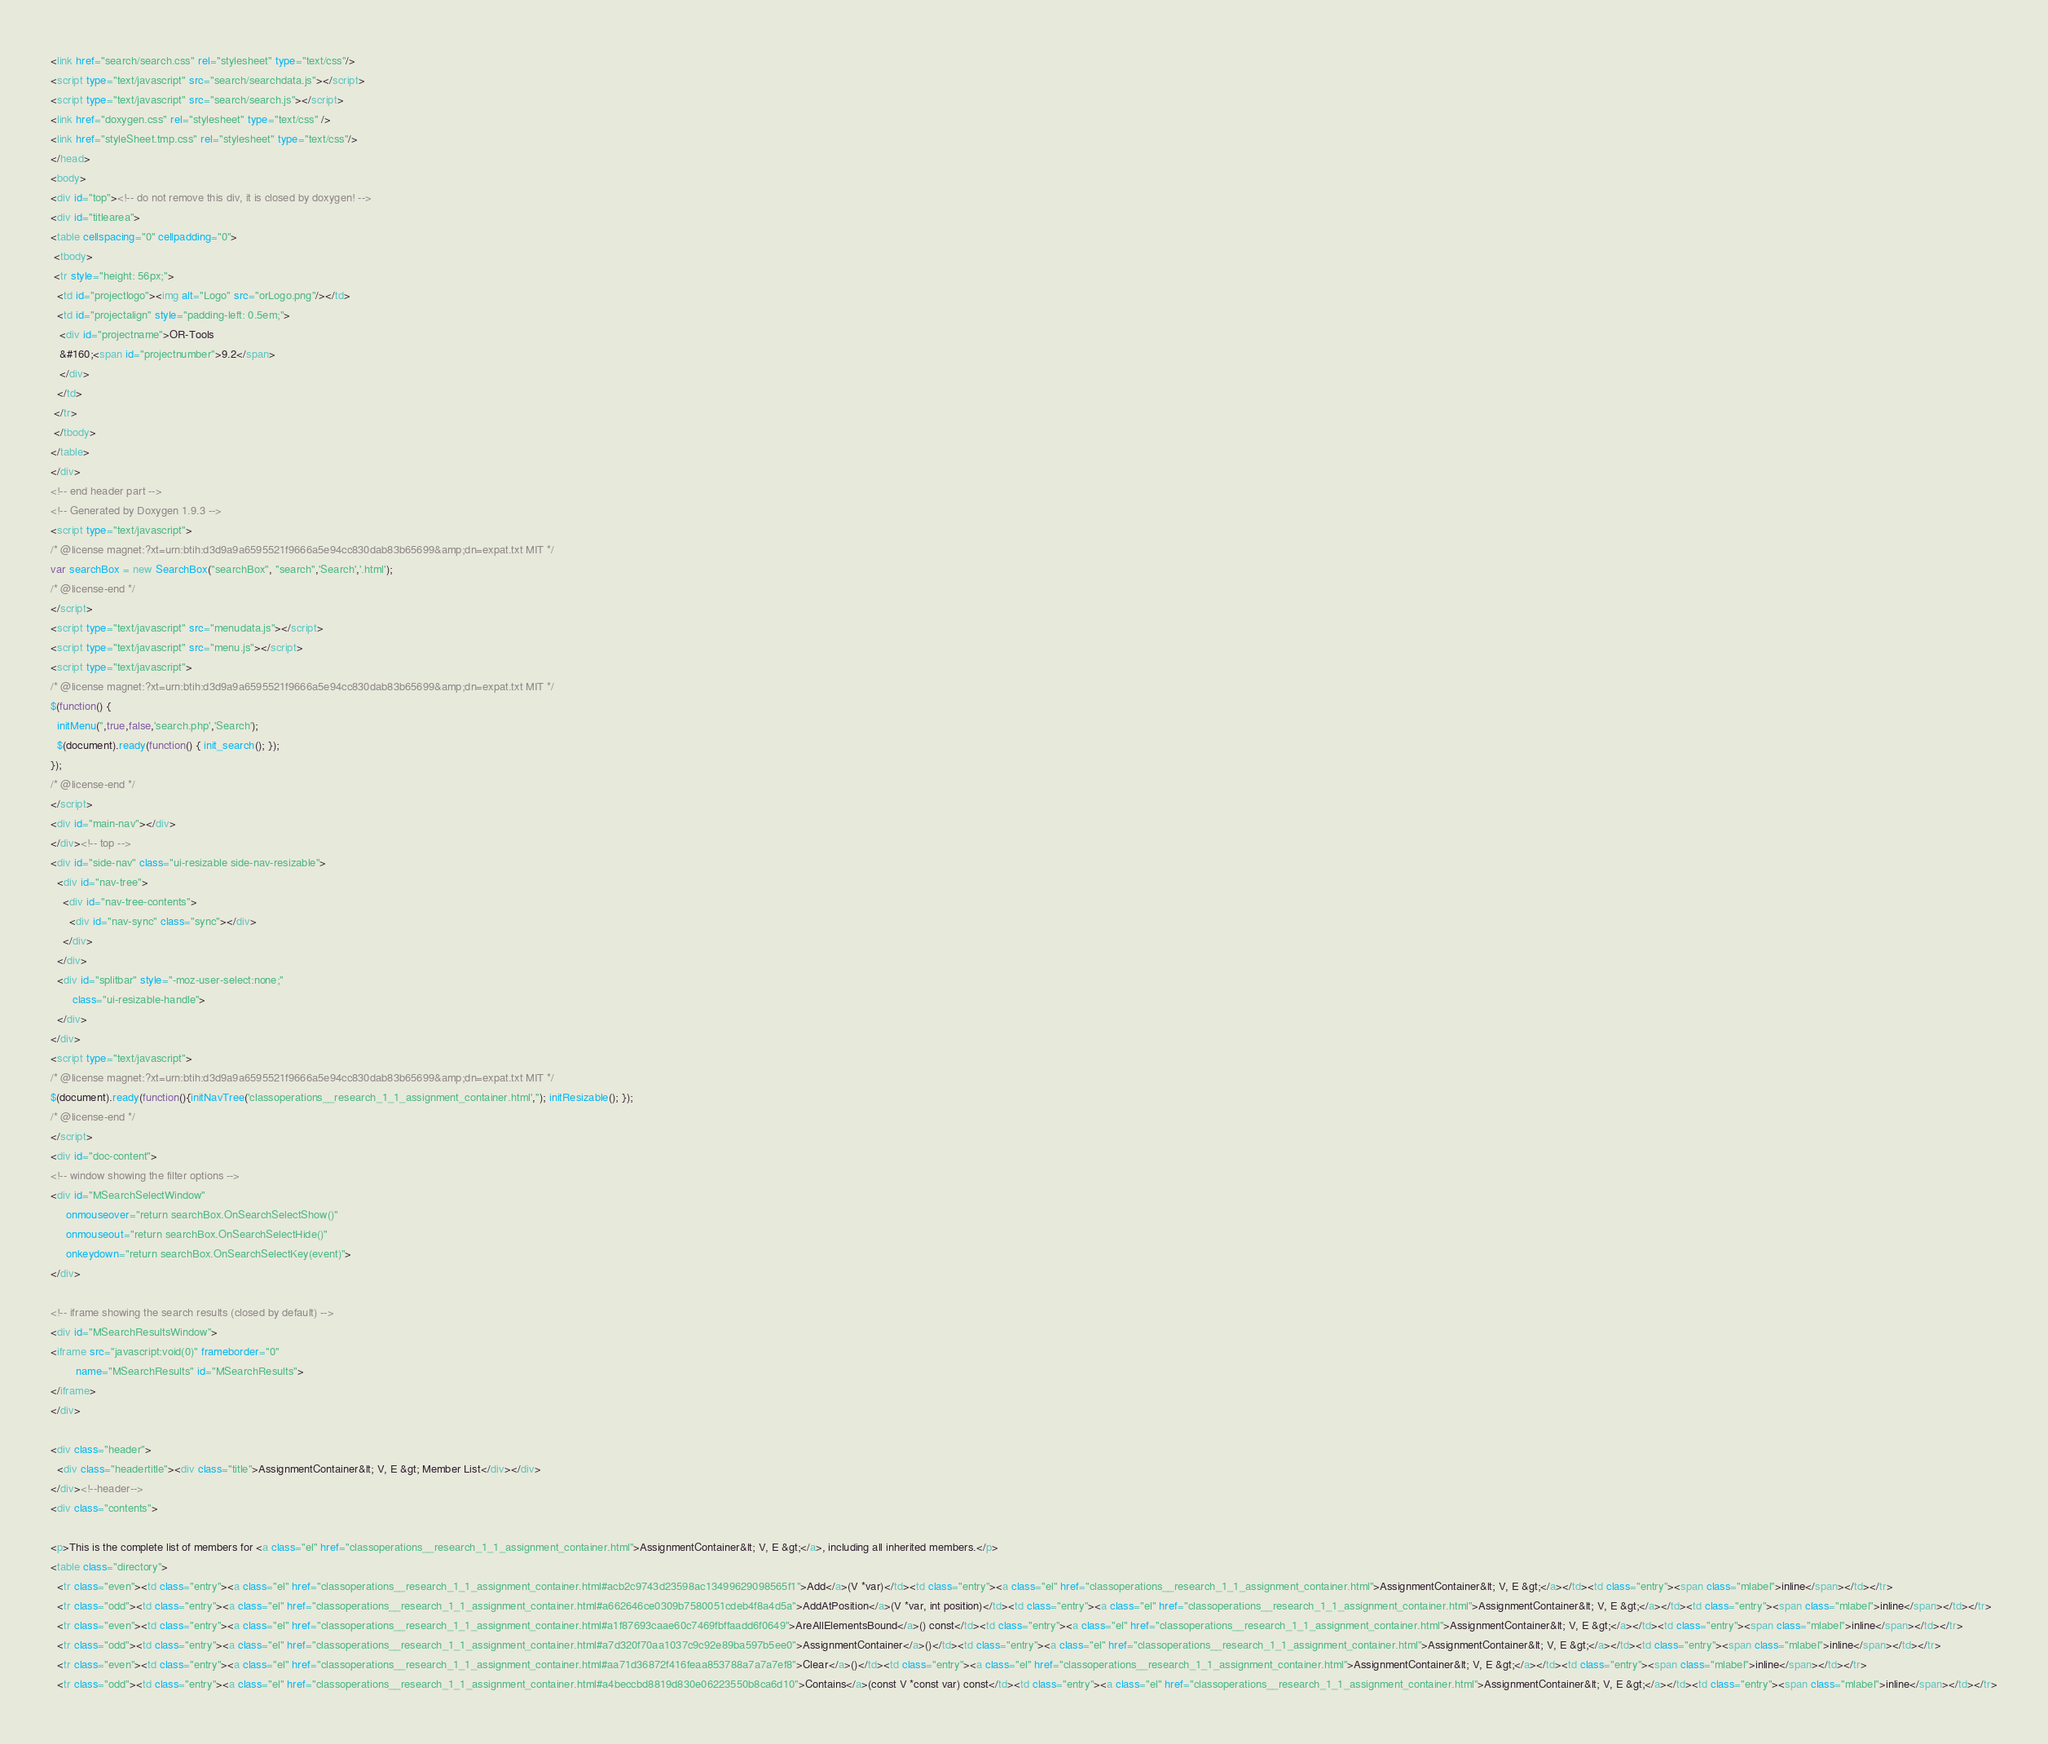<code> <loc_0><loc_0><loc_500><loc_500><_HTML_><link href="search/search.css" rel="stylesheet" type="text/css"/>
<script type="text/javascript" src="search/searchdata.js"></script>
<script type="text/javascript" src="search/search.js"></script>
<link href="doxygen.css" rel="stylesheet" type="text/css" />
<link href="styleSheet.tmp.css" rel="stylesheet" type="text/css"/>
</head>
<body>
<div id="top"><!-- do not remove this div, it is closed by doxygen! -->
<div id="titlearea">
<table cellspacing="0" cellpadding="0">
 <tbody>
 <tr style="height: 56px;">
  <td id="projectlogo"><img alt="Logo" src="orLogo.png"/></td>
  <td id="projectalign" style="padding-left: 0.5em;">
   <div id="projectname">OR-Tools
   &#160;<span id="projectnumber">9.2</span>
   </div>
  </td>
 </tr>
 </tbody>
</table>
</div>
<!-- end header part -->
<!-- Generated by Doxygen 1.9.3 -->
<script type="text/javascript">
/* @license magnet:?xt=urn:btih:d3d9a9a6595521f9666a5e94cc830dab83b65699&amp;dn=expat.txt MIT */
var searchBox = new SearchBox("searchBox", "search",'Search','.html');
/* @license-end */
</script>
<script type="text/javascript" src="menudata.js"></script>
<script type="text/javascript" src="menu.js"></script>
<script type="text/javascript">
/* @license magnet:?xt=urn:btih:d3d9a9a6595521f9666a5e94cc830dab83b65699&amp;dn=expat.txt MIT */
$(function() {
  initMenu('',true,false,'search.php','Search');
  $(document).ready(function() { init_search(); });
});
/* @license-end */
</script>
<div id="main-nav"></div>
</div><!-- top -->
<div id="side-nav" class="ui-resizable side-nav-resizable">
  <div id="nav-tree">
    <div id="nav-tree-contents">
      <div id="nav-sync" class="sync"></div>
    </div>
  </div>
  <div id="splitbar" style="-moz-user-select:none;" 
       class="ui-resizable-handle">
  </div>
</div>
<script type="text/javascript">
/* @license magnet:?xt=urn:btih:d3d9a9a6595521f9666a5e94cc830dab83b65699&amp;dn=expat.txt MIT */
$(document).ready(function(){initNavTree('classoperations__research_1_1_assignment_container.html',''); initResizable(); });
/* @license-end */
</script>
<div id="doc-content">
<!-- window showing the filter options -->
<div id="MSearchSelectWindow"
     onmouseover="return searchBox.OnSearchSelectShow()"
     onmouseout="return searchBox.OnSearchSelectHide()"
     onkeydown="return searchBox.OnSearchSelectKey(event)">
</div>

<!-- iframe showing the search results (closed by default) -->
<div id="MSearchResultsWindow">
<iframe src="javascript:void(0)" frameborder="0" 
        name="MSearchResults" id="MSearchResults">
</iframe>
</div>

<div class="header">
  <div class="headertitle"><div class="title">AssignmentContainer&lt; V, E &gt; Member List</div></div>
</div><!--header-->
<div class="contents">

<p>This is the complete list of members for <a class="el" href="classoperations__research_1_1_assignment_container.html">AssignmentContainer&lt; V, E &gt;</a>, including all inherited members.</p>
<table class="directory">
  <tr class="even"><td class="entry"><a class="el" href="classoperations__research_1_1_assignment_container.html#acb2c9743d23598ac13499629098565f1">Add</a>(V *var)</td><td class="entry"><a class="el" href="classoperations__research_1_1_assignment_container.html">AssignmentContainer&lt; V, E &gt;</a></td><td class="entry"><span class="mlabel">inline</span></td></tr>
  <tr class="odd"><td class="entry"><a class="el" href="classoperations__research_1_1_assignment_container.html#a662646ce0309b7580051cdeb4f8a4d5a">AddAtPosition</a>(V *var, int position)</td><td class="entry"><a class="el" href="classoperations__research_1_1_assignment_container.html">AssignmentContainer&lt; V, E &gt;</a></td><td class="entry"><span class="mlabel">inline</span></td></tr>
  <tr class="even"><td class="entry"><a class="el" href="classoperations__research_1_1_assignment_container.html#a1f87693caae60c7469fbffaadd6f0649">AreAllElementsBound</a>() const</td><td class="entry"><a class="el" href="classoperations__research_1_1_assignment_container.html">AssignmentContainer&lt; V, E &gt;</a></td><td class="entry"><span class="mlabel">inline</span></td></tr>
  <tr class="odd"><td class="entry"><a class="el" href="classoperations__research_1_1_assignment_container.html#a7d320f70aa1037c9c92e89ba597b5ee0">AssignmentContainer</a>()</td><td class="entry"><a class="el" href="classoperations__research_1_1_assignment_container.html">AssignmentContainer&lt; V, E &gt;</a></td><td class="entry"><span class="mlabel">inline</span></td></tr>
  <tr class="even"><td class="entry"><a class="el" href="classoperations__research_1_1_assignment_container.html#aa71d36872f416feaa853788a7a7a7ef8">Clear</a>()</td><td class="entry"><a class="el" href="classoperations__research_1_1_assignment_container.html">AssignmentContainer&lt; V, E &gt;</a></td><td class="entry"><span class="mlabel">inline</span></td></tr>
  <tr class="odd"><td class="entry"><a class="el" href="classoperations__research_1_1_assignment_container.html#a4beccbd8819d830e06223550b8ca6d10">Contains</a>(const V *const var) const</td><td class="entry"><a class="el" href="classoperations__research_1_1_assignment_container.html">AssignmentContainer&lt; V, E &gt;</a></td><td class="entry"><span class="mlabel">inline</span></td></tr></code> 